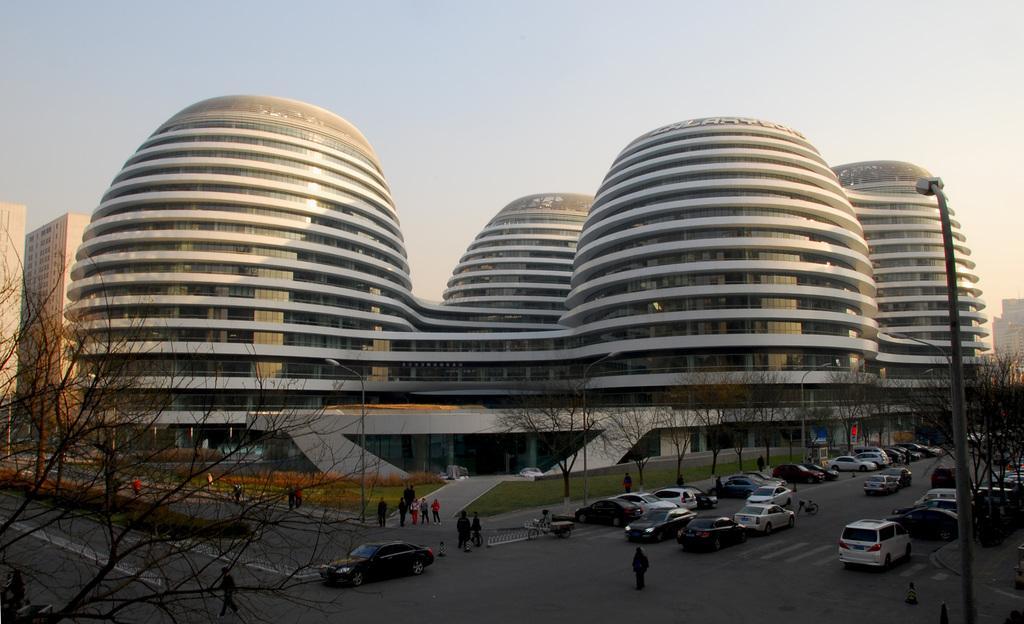Could you give a brief overview of what you see in this image? In this picture we can see few trees, poles, vehicles and group of people, in the background we can find few buildings. 